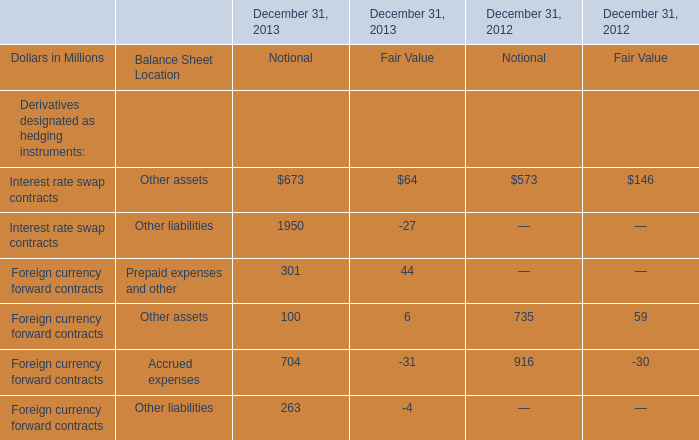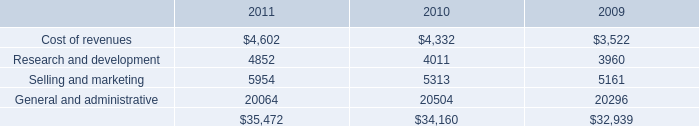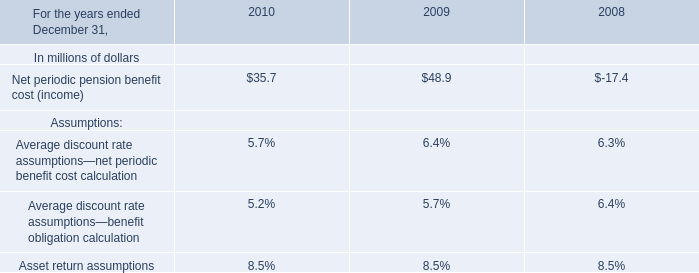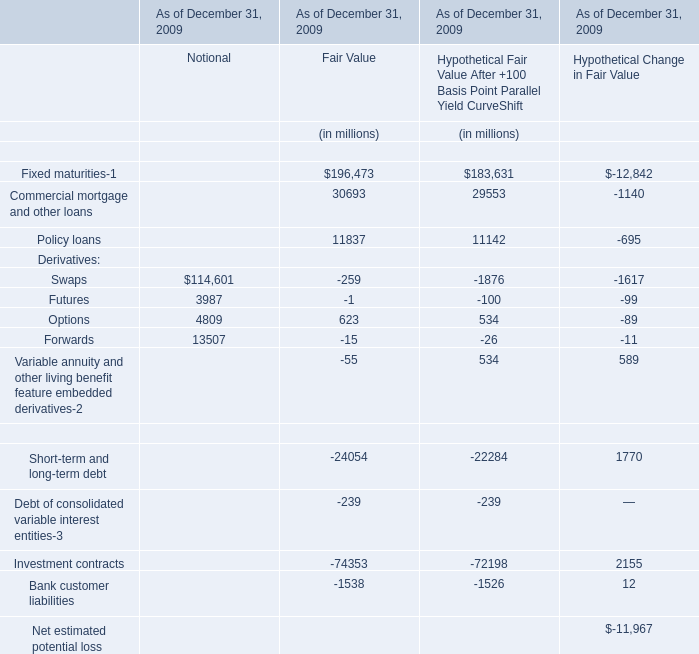What's the total value of all elements that are smaller than 10000 for Notional? (in million) 
Computations: (3987 + 4809)
Answer: 8796.0. 